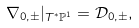Convert formula to latex. <formula><loc_0><loc_0><loc_500><loc_500>\nabla _ { 0 , \pm } | _ { T ^ { \ast } \mathbb { P } ^ { 1 } } = \mathcal { D } _ { 0 , \pm } ,</formula> 